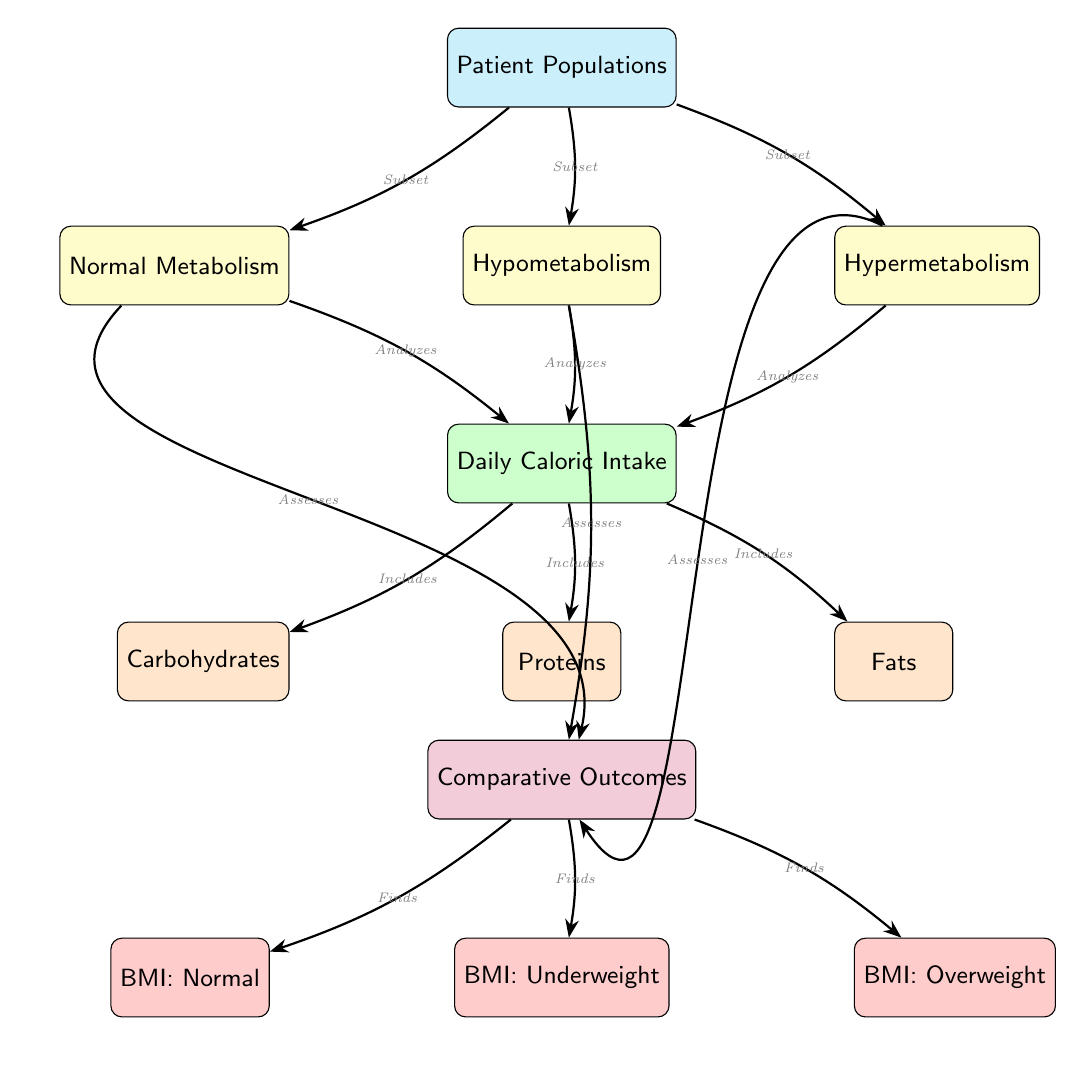What are the three types of patient populations represented? The diagram shows three patient populations: Normal Metabolism, Hypometabolism, and Hypermetabolism. These are explicitly labeled in the diagram under the main node "Patient Populations."
Answer: Normal Metabolism, Hypometabolism, Hypermetabolism Which metabolic pathway includes the analysis of daily caloric intake? The "Daily Caloric Intake" node is directly connected to all three metabolic pathways (Normal, Hypo, Hyper) through an edge labeled "Analyzes." This indicates that each pathway involves an analysis of caloric intake.
Answer: Normal Metabolism, Hypometabolism, Hypermetabolism How many types of food are included in the caloric intake? The "Daily Caloric Intake" node branches out to three nodes: Carbohydrates, Proteins, and Fats, indicating that there are three types of food included.
Answer: 3 What are the potential BMI outcomes assessed from the comparisons? The "Comparative Outcomes" node leads to three different BMI outcomes: Normal, Underweight, and Overweight. Each outcome is explicitly mentioned as a result of assessing the comparative data.
Answer: Normal, Underweight, Overweight Which patient population is tended to by the analysis labeled "Assesses" that targets comparative outcomes? The "Assesses" label for the analysis branches from the Normal Metabolism, Hypometabolism, and Hypermetabolism nodes to the Comparative Outcomes. This means that they all contribute to these assessments.
Answer: Normal Metabolism, Hypometabolism, Hypermetabolism What does the edge labeled "Includes" specify about daily caloric intake? The edge labeled "Includes" directly connects the "Daily Caloric Intake" node to the food nodes: Carbohydrates, Proteins, and Fats. This signifies that these types of food are components of the caloric intake.
Answer: Carbohydrates, Proteins, Fats Which populations have a specific associate to BMI: Overweight? The "BMI: Overweight" outcome is a resultant node from the "Comparative Outcomes" node, which is assessed by all three metabolic pathways. This indicates that all patient populations can potentially be associated with the overweight BMI category.
Answer: Normal Metabolism, Hypometabolism, Hypermetabolism Which interaction type connects the Patient Populations to their respective metabolism categories? The edges labeled "Subset" connect the "Patient Populations" node to each of the metabolic pathways, indicating that these populations are subsets of the broader patient populations.
Answer: Subset 